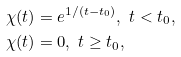<formula> <loc_0><loc_0><loc_500><loc_500>& \chi ( t ) = e ^ { 1 / ( t - t _ { 0 } ) } , \ t < t _ { 0 } , \\ & \chi ( t ) = 0 , \ t \geq t _ { 0 } ,</formula> 